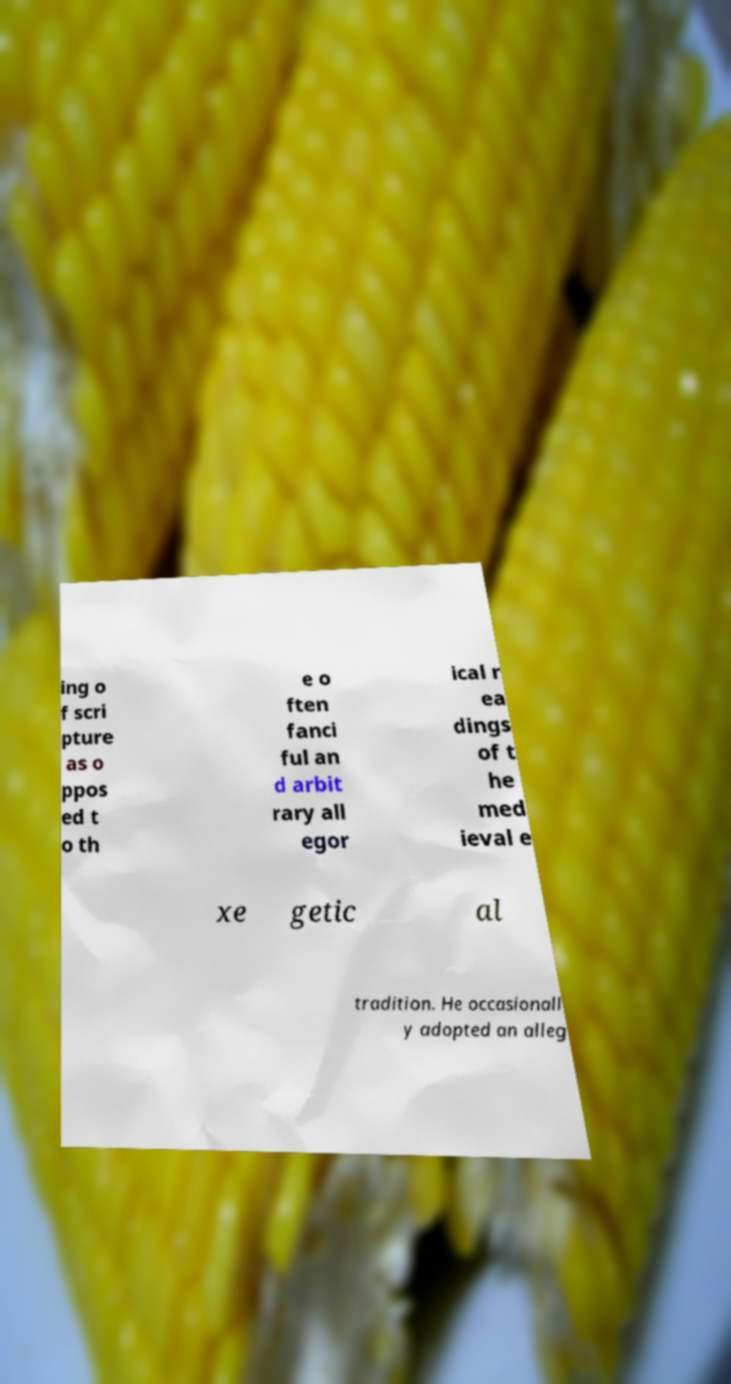Could you extract and type out the text from this image? ing o f scri pture as o ppos ed t o th e o ften fanci ful an d arbit rary all egor ical r ea dings of t he med ieval e xe getic al tradition. He occasionall y adopted an alleg 